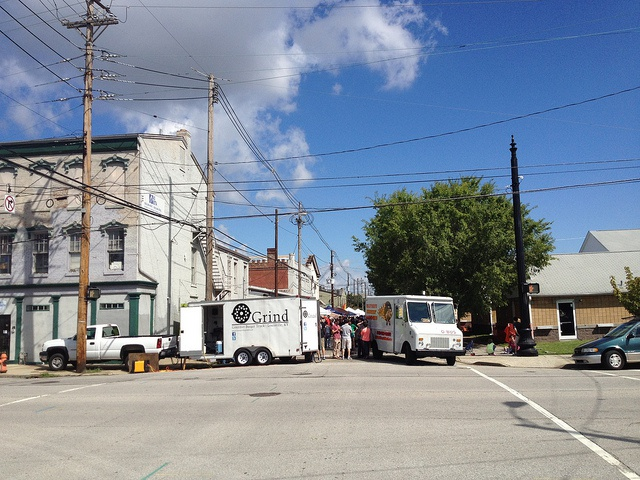Describe the objects in this image and their specific colors. I can see truck in gray, white, black, and darkgray tones, truck in gray, black, white, and darkgray tones, truck in gray, black, white, and darkgray tones, car in gray, black, blue, and navy tones, and people in gray, brown, maroon, tan, and black tones in this image. 